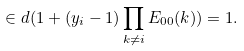<formula> <loc_0><loc_0><loc_500><loc_500>\in d ( 1 + ( y _ { i } - 1 ) \prod _ { k \neq i } E _ { 0 0 } ( k ) ) = 1 .</formula> 